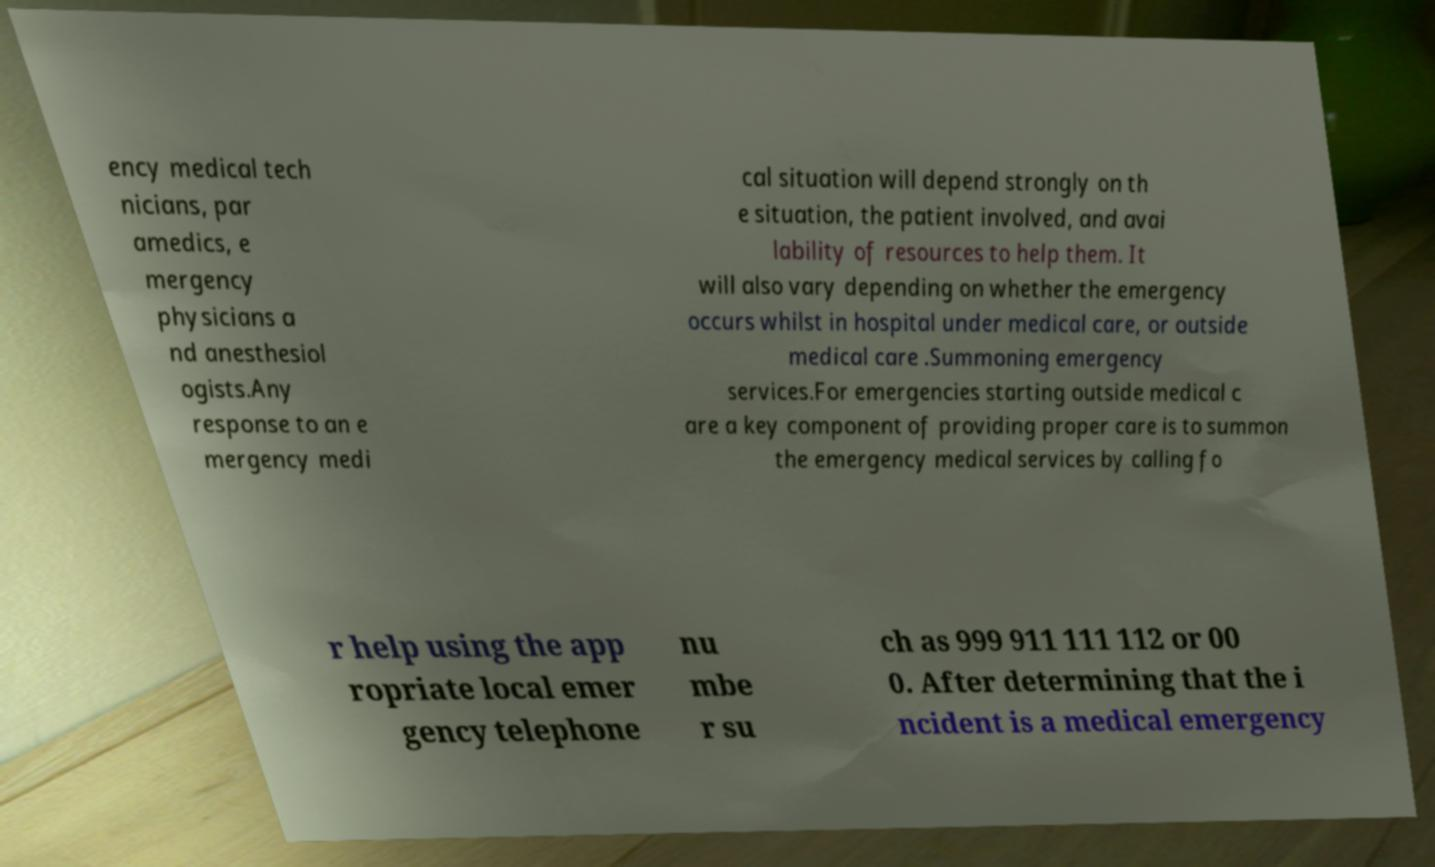I need the written content from this picture converted into text. Can you do that? ency medical tech nicians, par amedics, e mergency physicians a nd anesthesiol ogists.Any response to an e mergency medi cal situation will depend strongly on th e situation, the patient involved, and avai lability of resources to help them. It will also vary depending on whether the emergency occurs whilst in hospital under medical care, or outside medical care .Summoning emergency services.For emergencies starting outside medical c are a key component of providing proper care is to summon the emergency medical services by calling fo r help using the app ropriate local emer gency telephone nu mbe r su ch as 999 911 111 112 or 00 0. After determining that the i ncident is a medical emergency 